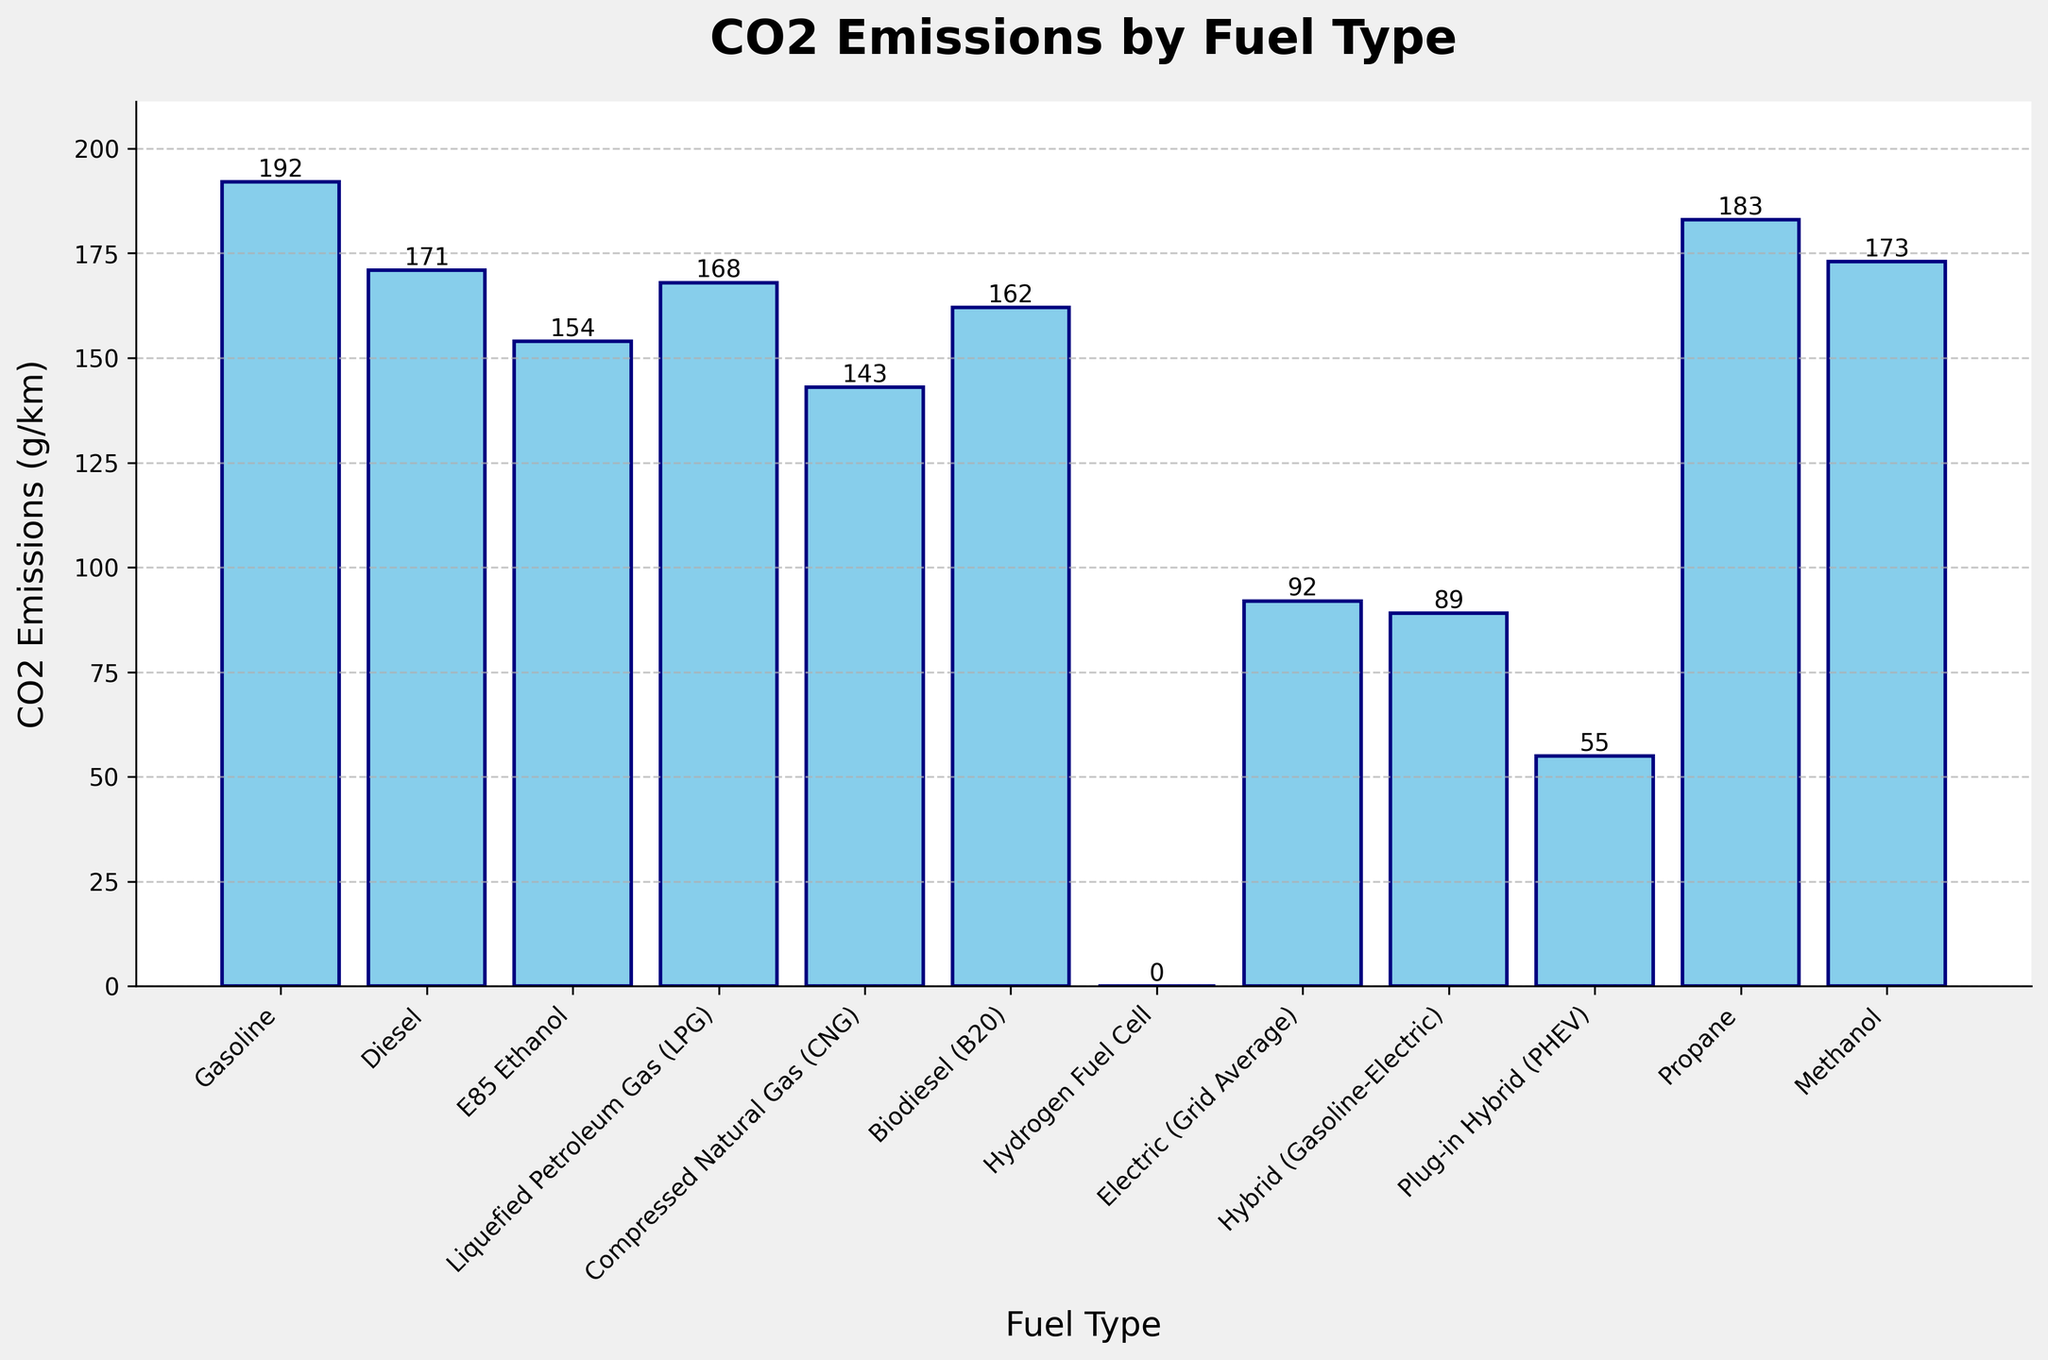Which fuel type has the highest CO2 emissions? Look for the tallest bar in the chart and identify the fuel type corresponding to that bar. The tallest bar represents the highest CO2 emissions.
Answer: Gasoline Which fuel type has the lowest CO2 emissions? Look for the shortest bar in the chart and identify the fuel type corresponding to that bar. The shortest bar represents the lowest CO2 emissions.
Answer: Hydrogen Fuel Cell Which fuel type emits more CO2, Methanol or Propane? Compare the heights of the bars for Methanol and Propane. The bar that is taller corresponds to the fuel type that emits more CO2.
Answer: Propane How much more CO2 does Diesel emit compared to E85 Ethanol? Find the heights of the bars for Diesel and E85 Ethanol. Subtract the height of the E85 Ethanol bar from the height of the Diesel bar to get the difference. Diesel: 171, E85 Ethanol: 154. The difference is 171 - 154 = 17 g/km.
Answer: 17 g/km Average CO2 emissions of Gasoline, Diesel, and Hybird (Gasoline-Electric)? Find the heights of the bars for Gasoline, Diesel, and Hybird (Gasoline-Electric). Sum these values and then divide by 3. (192 + 171 + 89) / 3 = 452 / 3 = 150.67 g/km.
Answer: 150.67 g/km Which fuel type shows zero CO2 emissions, and why might that be? Identify the bar with a height of zero and refer to the corresponding fuel type. Hydrogen Fuel Cell shows zero emissions, likely because it produces water vapor instead of CO2.
Answer: Hydrogen Fuel Cell Are the CO2 emissions for Compressed Natural Gas (CNG) less than those for Biodiesel (B20)? Compare the heights of the bars for Compressed Natural Gas (CNG) and Biodiesel (B20). The CO2 emissions are lower for the fuel type corresponding to the shorter bar.
Answer: Yes Which fuel types have CO2 emissions greater than 170 g/km? Identify the bars that exceed the height corresponding to 170 g/km and note the fuel types.
Answer: Gasoline, Propane, Methanol What's the total CO2 emission for Electric (Grid Average) and Plug-in Hybrid (PHEV)? Find the heights of the bars for Electric (Grid Average) and Plug-in Hybrid (PHEV). Sum these values to find the total CO2 emissions. Electric: 92, PHEV: 55. 92 + 55 = 147 g/km.
Answer: 147 g/km Order the fuel types by CO2 emissions in ascending order. List the fuel types according to the increasing height of their bars.
Answer: Hydrogen Fuel Cell, Plug-in Hybrid (PHEV), Hybrid (Gasoline-Electric), Electric (Grid Average), Compressed Natural Gas (CNG), E85 Ethanol, Biodiesel (B20), Liquefied Petroleum Gas (LPG), Diesel, Methanol, Propane, Gasoline 